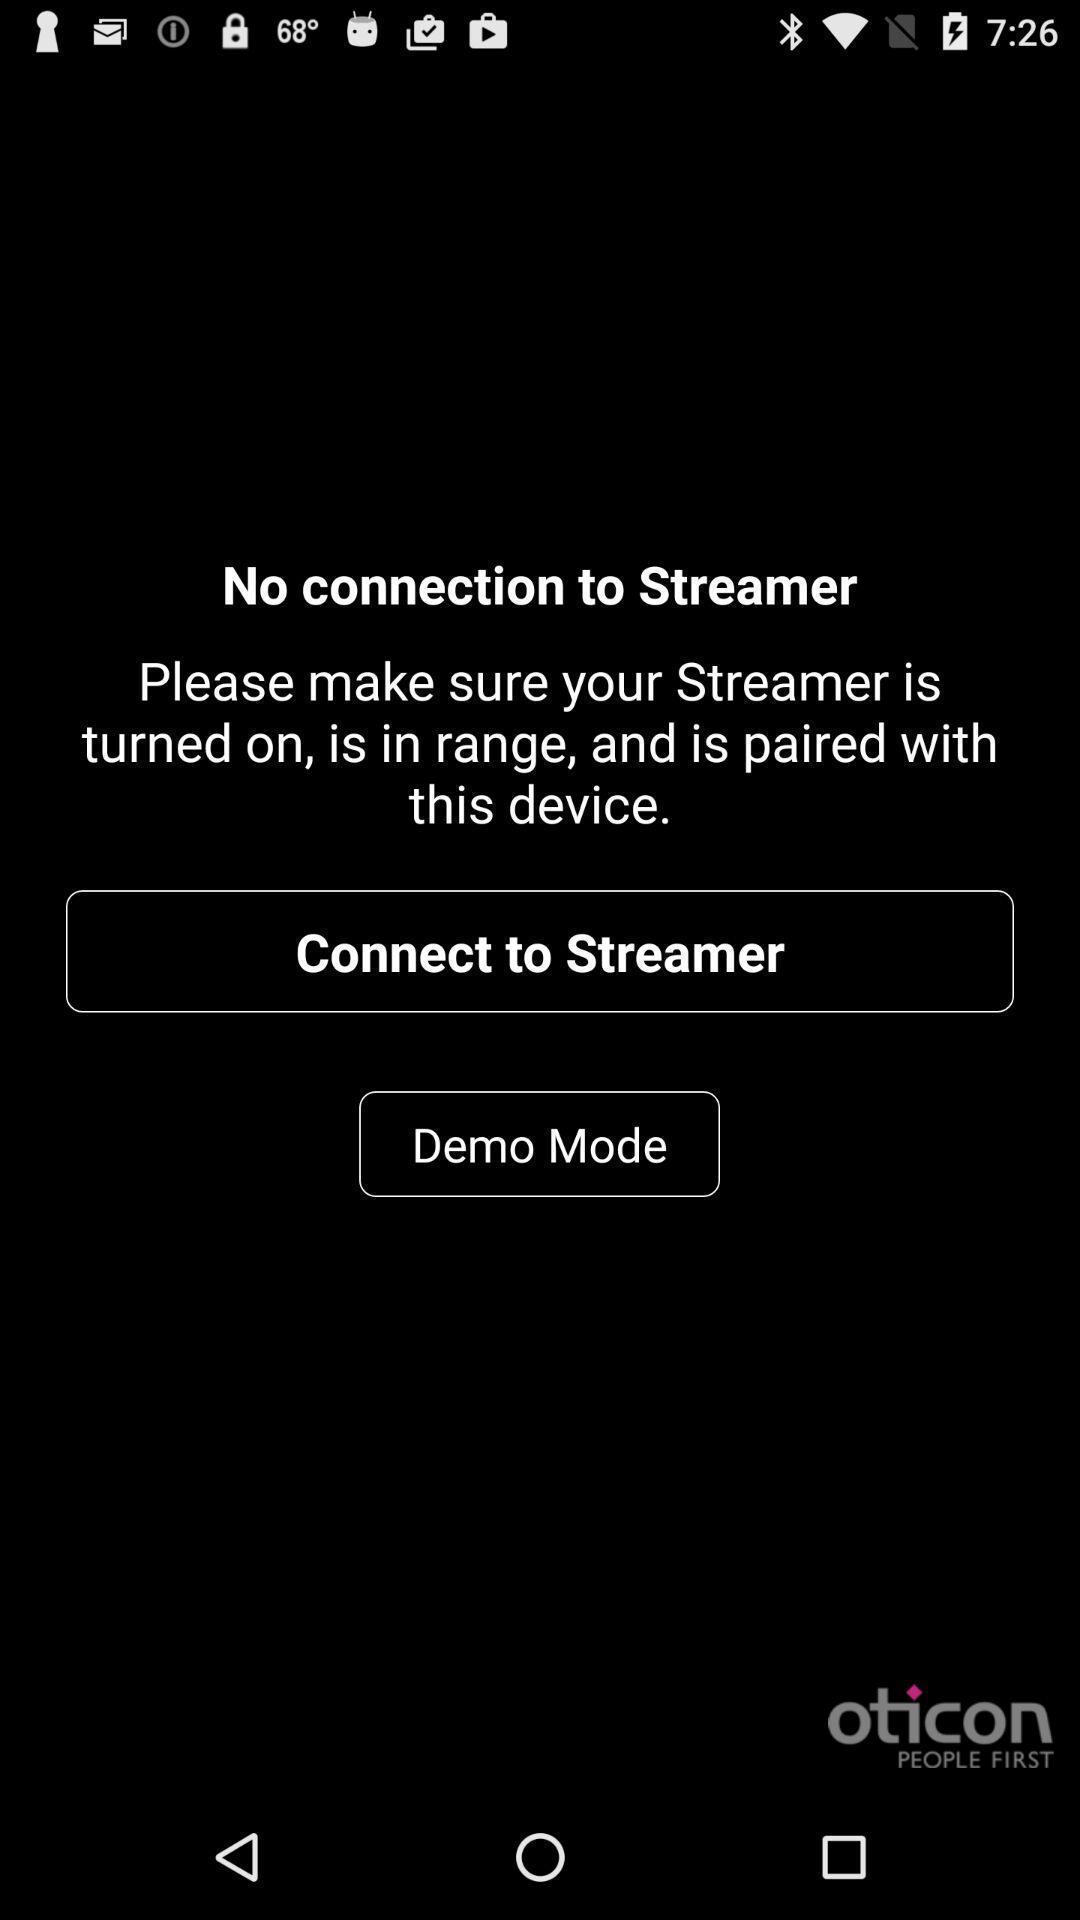Describe the visual elements of this screenshot. Screen showing no connection to streamer. 